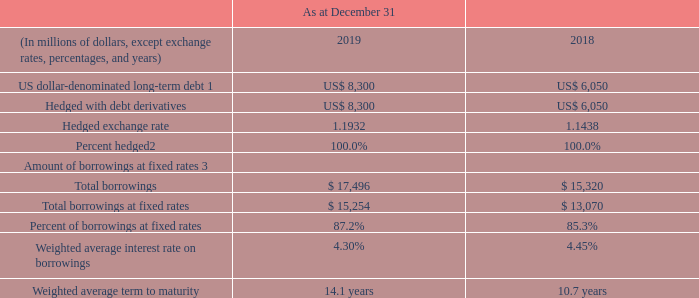As at December 31, 2019, we had US$8.3 billion of US dollardenominated senior notes and debentures, all of which were hedged using debt derivatives.
1 US dollar-denominated long-term debt reflects the hedged exchange rate and the hedged interest rate.
2 Pursuant to the requirements for hedge accounting under IFRS 9, Financial instruments, as at December 31, 2019 and December 31, 2018, RCI accounted for 100% of its debt derivatives related to senior notes as hedges against designated US dollar-denominated debt. As a result, as at December 31, 2019 and 2018, 100% of our US dollar-denominated senior notes and debentures are hedged for accounting and economic purposes.
3 Borrowings include long-term debt, including the impact of debt derivatives, and short-term borrowings associated with our US CP and accounts receivable securitization programs.
What percentage of US dollar-denominated senior notes and debentures are hedged for accounting and economic purposes? 100%. What components are included under borrowings? Long-term debt, including the impact of debt derivatives, and short-term borrowings associated with our us cp and accounts receivable securitization programs. What was the hedged exchange rate in 2019? 1.1932. What was the increase / (decrease) in US dollar-denominated long-term debt from 2018 to 2019?
Answer scale should be: million. 8,300 - 6,050
Answer: 2250. What was the average Hedged with debt derivatives?
Answer scale should be: million. (8,300 + 6,050) / 2
Answer: 7175. What was the increase / (decrease) in Total borrowings from 2018 to 2019?
Answer scale should be: million. 17,496 - 15,320
Answer: 2176. 